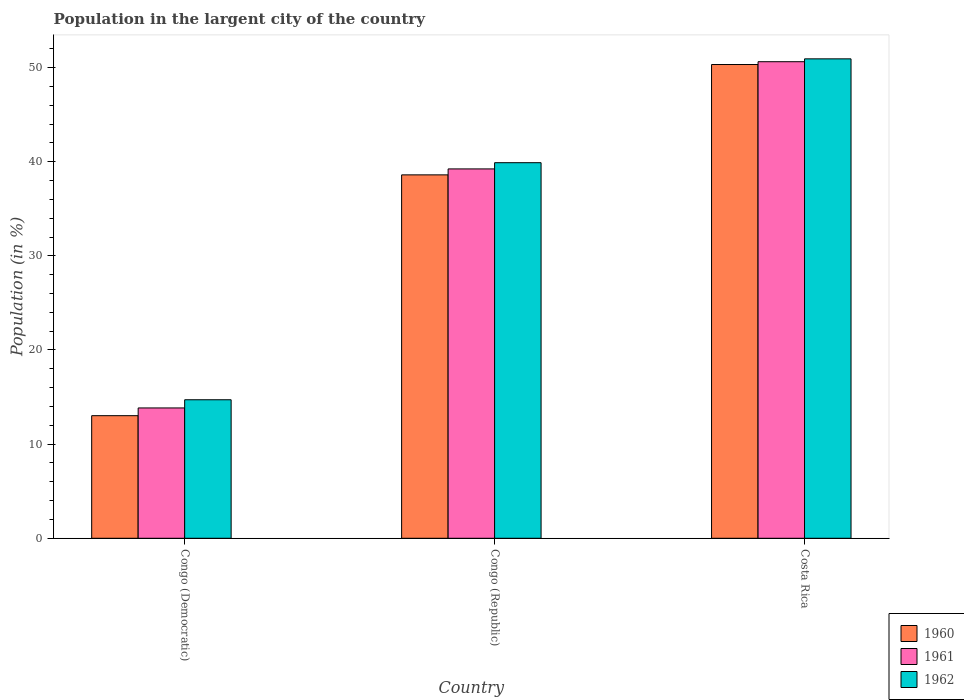How many groups of bars are there?
Provide a succinct answer. 3. Are the number of bars on each tick of the X-axis equal?
Give a very brief answer. Yes. How many bars are there on the 2nd tick from the left?
Offer a terse response. 3. How many bars are there on the 1st tick from the right?
Keep it short and to the point. 3. What is the percentage of population in the largent city in 1962 in Congo (Republic)?
Ensure brevity in your answer.  39.9. Across all countries, what is the maximum percentage of population in the largent city in 1961?
Your answer should be compact. 50.62. Across all countries, what is the minimum percentage of population in the largent city in 1960?
Give a very brief answer. 13.02. In which country was the percentage of population in the largent city in 1961 maximum?
Give a very brief answer. Costa Rica. In which country was the percentage of population in the largent city in 1962 minimum?
Your answer should be compact. Congo (Democratic). What is the total percentage of population in the largent city in 1962 in the graph?
Offer a terse response. 105.54. What is the difference between the percentage of population in the largent city in 1960 in Congo (Democratic) and that in Costa Rica?
Your response must be concise. -37.3. What is the difference between the percentage of population in the largent city in 1960 in Congo (Democratic) and the percentage of population in the largent city in 1962 in Congo (Republic)?
Your answer should be very brief. -26.87. What is the average percentage of population in the largent city in 1961 per country?
Make the answer very short. 34.57. What is the difference between the percentage of population in the largent city of/in 1961 and percentage of population in the largent city of/in 1962 in Costa Rica?
Give a very brief answer. -0.3. In how many countries, is the percentage of population in the largent city in 1962 greater than 2 %?
Offer a terse response. 3. What is the ratio of the percentage of population in the largent city in 1961 in Congo (Democratic) to that in Costa Rica?
Ensure brevity in your answer.  0.27. Is the difference between the percentage of population in the largent city in 1961 in Congo (Democratic) and Costa Rica greater than the difference between the percentage of population in the largent city in 1962 in Congo (Democratic) and Costa Rica?
Your answer should be compact. No. What is the difference between the highest and the second highest percentage of population in the largent city in 1962?
Provide a short and direct response. 36.21. What is the difference between the highest and the lowest percentage of population in the largent city in 1960?
Keep it short and to the point. 37.3. Is the sum of the percentage of population in the largent city in 1962 in Congo (Democratic) and Congo (Republic) greater than the maximum percentage of population in the largent city in 1960 across all countries?
Make the answer very short. Yes. Is it the case that in every country, the sum of the percentage of population in the largent city in 1962 and percentage of population in the largent city in 1960 is greater than the percentage of population in the largent city in 1961?
Offer a terse response. Yes. How many bars are there?
Your answer should be compact. 9. What is the difference between two consecutive major ticks on the Y-axis?
Make the answer very short. 10. How are the legend labels stacked?
Your answer should be compact. Vertical. What is the title of the graph?
Make the answer very short. Population in the largent city of the country. What is the label or title of the Y-axis?
Provide a succinct answer. Population (in %). What is the Population (in %) of 1960 in Congo (Democratic)?
Make the answer very short. 13.02. What is the Population (in %) in 1961 in Congo (Democratic)?
Your answer should be very brief. 13.84. What is the Population (in %) of 1962 in Congo (Democratic)?
Give a very brief answer. 14.71. What is the Population (in %) of 1960 in Congo (Republic)?
Provide a succinct answer. 38.6. What is the Population (in %) in 1961 in Congo (Republic)?
Give a very brief answer. 39.23. What is the Population (in %) in 1962 in Congo (Republic)?
Your answer should be very brief. 39.9. What is the Population (in %) of 1960 in Costa Rica?
Offer a very short reply. 50.32. What is the Population (in %) of 1961 in Costa Rica?
Offer a very short reply. 50.62. What is the Population (in %) in 1962 in Costa Rica?
Make the answer very short. 50.93. Across all countries, what is the maximum Population (in %) of 1960?
Ensure brevity in your answer.  50.32. Across all countries, what is the maximum Population (in %) in 1961?
Make the answer very short. 50.62. Across all countries, what is the maximum Population (in %) of 1962?
Provide a succinct answer. 50.93. Across all countries, what is the minimum Population (in %) of 1960?
Your response must be concise. 13.02. Across all countries, what is the minimum Population (in %) in 1961?
Offer a very short reply. 13.84. Across all countries, what is the minimum Population (in %) in 1962?
Offer a very short reply. 14.71. What is the total Population (in %) of 1960 in the graph?
Offer a terse response. 101.95. What is the total Population (in %) in 1961 in the graph?
Offer a terse response. 103.7. What is the total Population (in %) in 1962 in the graph?
Give a very brief answer. 105.54. What is the difference between the Population (in %) of 1960 in Congo (Democratic) and that in Congo (Republic)?
Your response must be concise. -25.58. What is the difference between the Population (in %) of 1961 in Congo (Democratic) and that in Congo (Republic)?
Your answer should be compact. -25.39. What is the difference between the Population (in %) of 1962 in Congo (Democratic) and that in Congo (Republic)?
Your answer should be compact. -25.18. What is the difference between the Population (in %) of 1960 in Congo (Democratic) and that in Costa Rica?
Offer a very short reply. -37.3. What is the difference between the Population (in %) in 1961 in Congo (Democratic) and that in Costa Rica?
Your response must be concise. -36.78. What is the difference between the Population (in %) in 1962 in Congo (Democratic) and that in Costa Rica?
Your response must be concise. -36.21. What is the difference between the Population (in %) in 1960 in Congo (Republic) and that in Costa Rica?
Provide a short and direct response. -11.72. What is the difference between the Population (in %) in 1961 in Congo (Republic) and that in Costa Rica?
Your answer should be compact. -11.39. What is the difference between the Population (in %) of 1962 in Congo (Republic) and that in Costa Rica?
Make the answer very short. -11.03. What is the difference between the Population (in %) of 1960 in Congo (Democratic) and the Population (in %) of 1961 in Congo (Republic)?
Your answer should be very brief. -26.21. What is the difference between the Population (in %) of 1960 in Congo (Democratic) and the Population (in %) of 1962 in Congo (Republic)?
Your answer should be very brief. -26.87. What is the difference between the Population (in %) of 1961 in Congo (Democratic) and the Population (in %) of 1962 in Congo (Republic)?
Your answer should be compact. -26.05. What is the difference between the Population (in %) in 1960 in Congo (Democratic) and the Population (in %) in 1961 in Costa Rica?
Your response must be concise. -37.6. What is the difference between the Population (in %) of 1960 in Congo (Democratic) and the Population (in %) of 1962 in Costa Rica?
Keep it short and to the point. -37.9. What is the difference between the Population (in %) of 1961 in Congo (Democratic) and the Population (in %) of 1962 in Costa Rica?
Offer a terse response. -37.08. What is the difference between the Population (in %) of 1960 in Congo (Republic) and the Population (in %) of 1961 in Costa Rica?
Provide a succinct answer. -12.02. What is the difference between the Population (in %) in 1960 in Congo (Republic) and the Population (in %) in 1962 in Costa Rica?
Your response must be concise. -12.32. What is the difference between the Population (in %) in 1961 in Congo (Republic) and the Population (in %) in 1962 in Costa Rica?
Offer a terse response. -11.69. What is the average Population (in %) of 1960 per country?
Your response must be concise. 33.98. What is the average Population (in %) of 1961 per country?
Your response must be concise. 34.57. What is the average Population (in %) in 1962 per country?
Provide a succinct answer. 35.18. What is the difference between the Population (in %) of 1960 and Population (in %) of 1961 in Congo (Democratic)?
Offer a terse response. -0.82. What is the difference between the Population (in %) of 1960 and Population (in %) of 1962 in Congo (Democratic)?
Your response must be concise. -1.69. What is the difference between the Population (in %) in 1961 and Population (in %) in 1962 in Congo (Democratic)?
Give a very brief answer. -0.87. What is the difference between the Population (in %) in 1960 and Population (in %) in 1961 in Congo (Republic)?
Keep it short and to the point. -0.63. What is the difference between the Population (in %) of 1960 and Population (in %) of 1962 in Congo (Republic)?
Make the answer very short. -1.29. What is the difference between the Population (in %) of 1961 and Population (in %) of 1962 in Congo (Republic)?
Give a very brief answer. -0.66. What is the difference between the Population (in %) in 1960 and Population (in %) in 1961 in Costa Rica?
Your answer should be compact. -0.3. What is the difference between the Population (in %) of 1960 and Population (in %) of 1962 in Costa Rica?
Give a very brief answer. -0.6. What is the difference between the Population (in %) in 1961 and Population (in %) in 1962 in Costa Rica?
Your answer should be very brief. -0.3. What is the ratio of the Population (in %) of 1960 in Congo (Democratic) to that in Congo (Republic)?
Give a very brief answer. 0.34. What is the ratio of the Population (in %) in 1961 in Congo (Democratic) to that in Congo (Republic)?
Your answer should be very brief. 0.35. What is the ratio of the Population (in %) in 1962 in Congo (Democratic) to that in Congo (Republic)?
Give a very brief answer. 0.37. What is the ratio of the Population (in %) in 1960 in Congo (Democratic) to that in Costa Rica?
Offer a very short reply. 0.26. What is the ratio of the Population (in %) in 1961 in Congo (Democratic) to that in Costa Rica?
Make the answer very short. 0.27. What is the ratio of the Population (in %) in 1962 in Congo (Democratic) to that in Costa Rica?
Keep it short and to the point. 0.29. What is the ratio of the Population (in %) of 1960 in Congo (Republic) to that in Costa Rica?
Offer a terse response. 0.77. What is the ratio of the Population (in %) in 1961 in Congo (Republic) to that in Costa Rica?
Keep it short and to the point. 0.78. What is the ratio of the Population (in %) in 1962 in Congo (Republic) to that in Costa Rica?
Offer a very short reply. 0.78. What is the difference between the highest and the second highest Population (in %) in 1960?
Ensure brevity in your answer.  11.72. What is the difference between the highest and the second highest Population (in %) of 1961?
Give a very brief answer. 11.39. What is the difference between the highest and the second highest Population (in %) of 1962?
Offer a very short reply. 11.03. What is the difference between the highest and the lowest Population (in %) of 1960?
Offer a terse response. 37.3. What is the difference between the highest and the lowest Population (in %) of 1961?
Offer a very short reply. 36.78. What is the difference between the highest and the lowest Population (in %) of 1962?
Offer a very short reply. 36.21. 